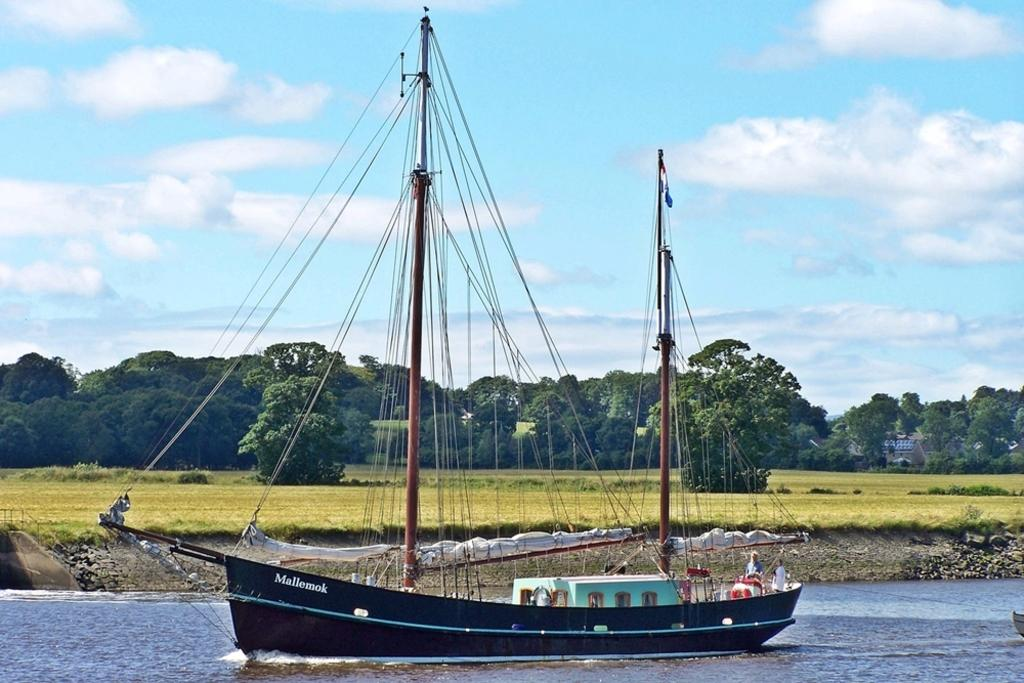What is the main subject of the image? The main subject of the image is a boat. Where is the boat located? The boat is on the water. What can be seen in the background of the image? There are trees and grass in the background of the image. How would you describe the sky in the image? The sky is blue and has clouds in it. Is there a woman in the image who appears to be afraid of the boat? There is no woman present in the image, and no indication of fear related to the boat. 